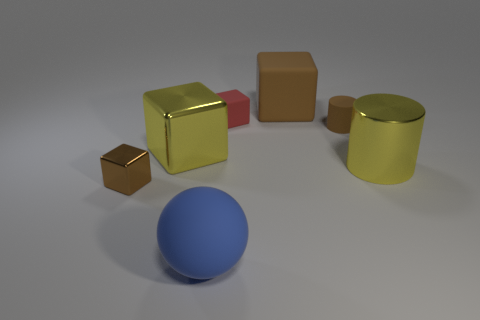If this were a scene from a video game, what kind of game do you think it would be and why? Based on the simplistic and geometric nature of the objects, this scene might belong to a puzzle or educational game where the player could be required to manipulate or arrange the shapes in a certain order. The 3D rendering and shadows also suggest it could be part of an interactive environment where these elements contribute to game challenges or serve as visual clues. 